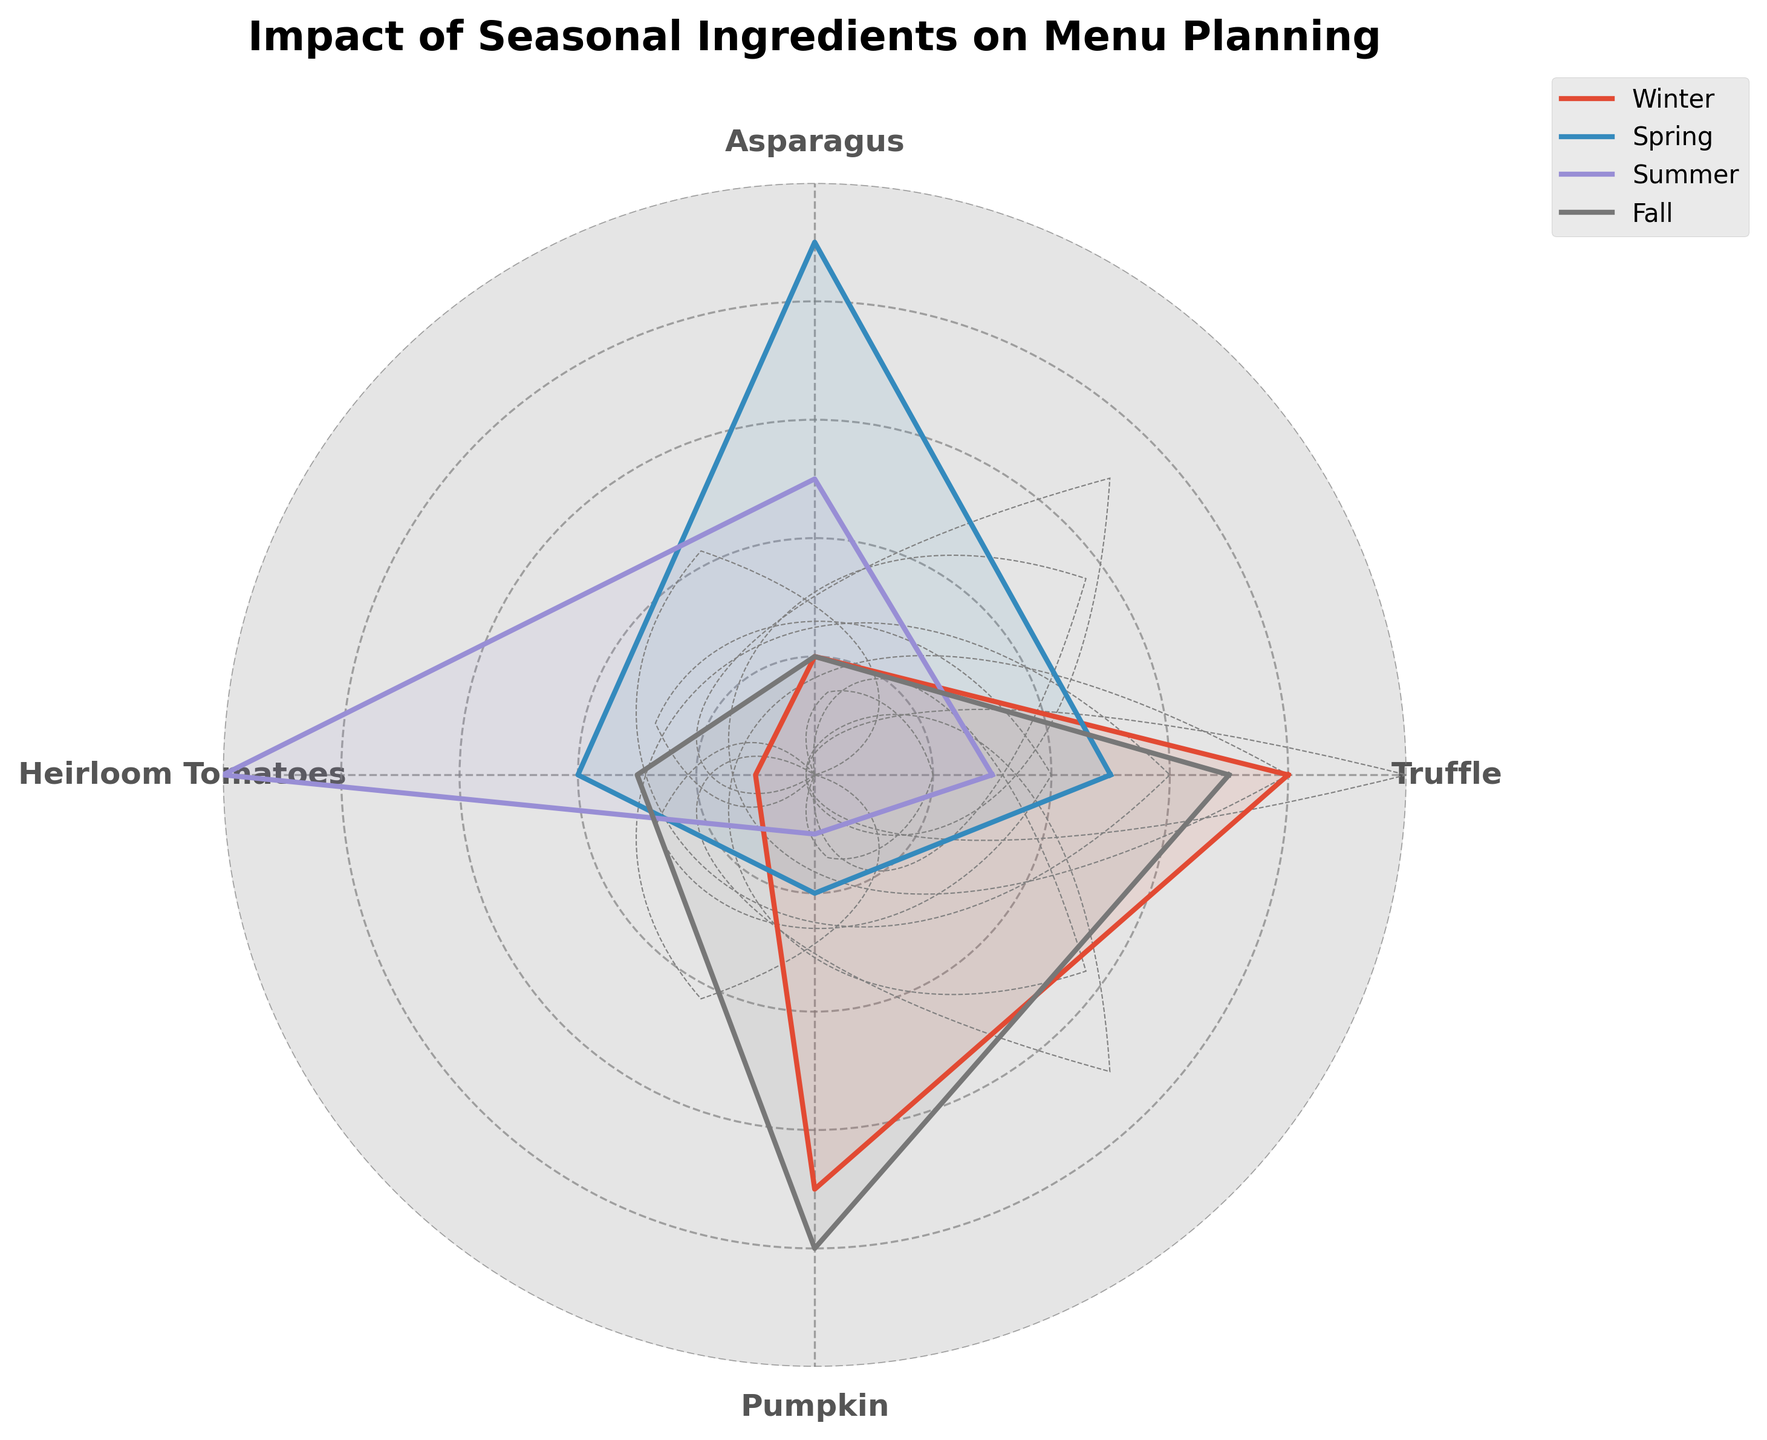What is the title of the radar chart? The radar chart title is displayed at the top and provides a summary of the figure’s subject.
Answer: Impact of Seasonal Ingredients on Menu Planning Which ingredient has the highest value in winter? By looking at the winter values along the corresponding line, the ingredient with the highest value can be identified. Truffle has the highest value in winter with a value of 8.
Answer: Truffle In which season is asparagus most influential? By comparing the values of asparagus across all seasons, the season with the highest value indicates its maximum influence. Asparagus has the highest value of 9 in spring.
Answer: Spring How does the influence of pumpkin compare between summer and fall? Find the values for pumpkin in both summer and fall and compare them. Pumpkin has a value of 1 in summer and a value of 8 in fall, indicating a significantly higher influence in fall.
Answer: Pumpkin has more influence in fall than in summer Rank the ingredients in descending order of their influence during summer. Compare the summer values for all ingredients and rank them from highest to lowest. The ranking is: Heirloom Tomatoes (10), Asparagus (5), Truffle (3), Pumpkin (1).
Answer: Heirloom Tomatoes, Asparagus, Truffle, Pumpkin Which ingredient shows the most consistent influence across all seasons? Examine the values of each ingredient across all seasons and identify the one with the least variation. Truffle has values of 8, 5, 3, and 7, showing relatively consistent influence.
Answer: Truffle What is the average influence of heirloom tomatoes across all seasons? Sum the values for heirloom tomatoes and divide by the number of seasons. (1+4+10+3) / 4 = 4.5.
Answer: 4.5 Between winter and spring, which ingredient shows the largest increase in influence? Calculate the difference between winter and spring values for each ingredient, and determine the one with the largest positive difference. Asparagus increases from 2 to 9, which is an increase of 7.
Answer: Asparagus Is there any ingredient whose influence decreases consistently from winter to summer and then increases in fall? Analyze the trends in the values for each ingredient from winter through fall. Truffle decreases from 8 (winter) to 3 (summer) and then increases to 7 (fall).
Answer: Truffle Which season has the highest average influence for all ingredients combined? Calculate the average value for each season and compare them. Winter: (8+2+1+7)/4 = 4.5, Spring: (5+9+4+2)/4 = 5, Summer: (3+5+10+1)/4 = 4.75, Fall: (7+2+3+8)/4 = 5.
Answer: Spring and Fall 